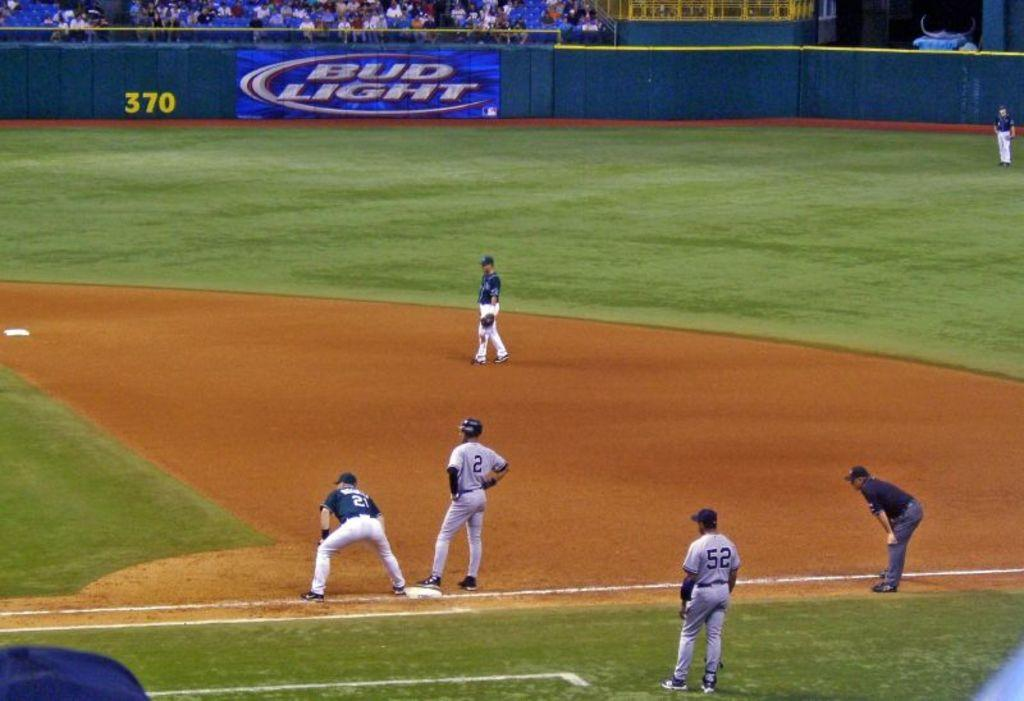<image>
Present a compact description of the photo's key features. Bud Light is one of the sponsors for the baseball game. 